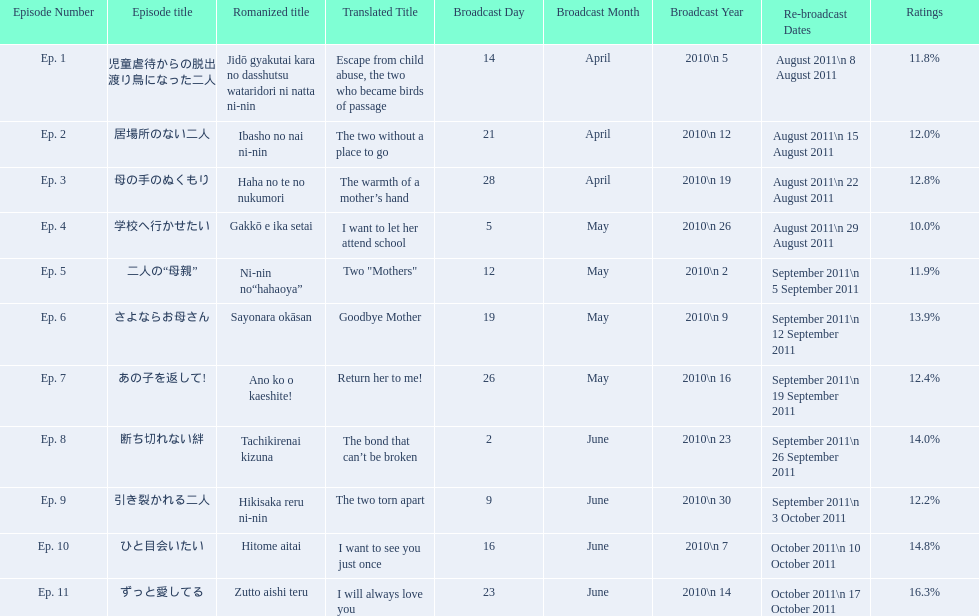What are the episode numbers? Ep. 1, Ep. 2, Ep. 3, Ep. 4, Ep. 5, Ep. 6, Ep. 7, Ep. 8, Ep. 9, Ep. 10, Ep. 11. What was the percentage of total ratings for episode 8? 14.0%. 